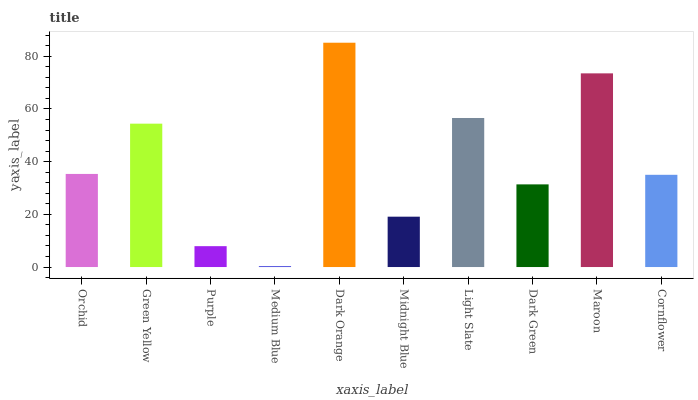Is Medium Blue the minimum?
Answer yes or no. Yes. Is Dark Orange the maximum?
Answer yes or no. Yes. Is Green Yellow the minimum?
Answer yes or no. No. Is Green Yellow the maximum?
Answer yes or no. No. Is Green Yellow greater than Orchid?
Answer yes or no. Yes. Is Orchid less than Green Yellow?
Answer yes or no. Yes. Is Orchid greater than Green Yellow?
Answer yes or no. No. Is Green Yellow less than Orchid?
Answer yes or no. No. Is Orchid the high median?
Answer yes or no. Yes. Is Cornflower the low median?
Answer yes or no. Yes. Is Cornflower the high median?
Answer yes or no. No. Is Orchid the low median?
Answer yes or no. No. 